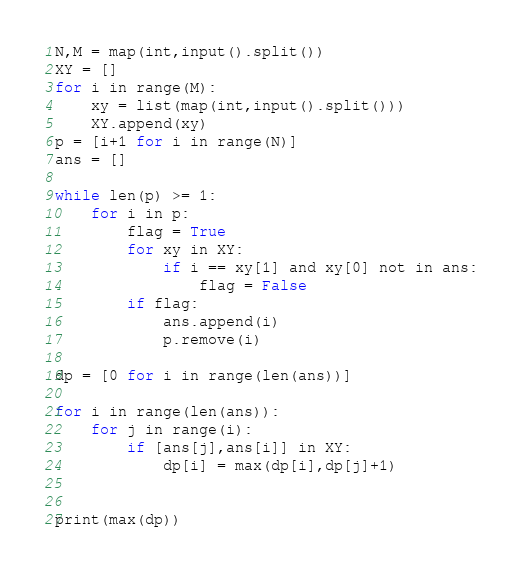Convert code to text. <code><loc_0><loc_0><loc_500><loc_500><_Python_>N,M = map(int,input().split())
XY = []
for i in range(M):
    xy = list(map(int,input().split()))
    XY.append(xy)
p = [i+1 for i in range(N)]
ans = []

while len(p) >= 1:
    for i in p:
        flag = True
        for xy in XY:
            if i == xy[1] and xy[0] not in ans:
                flag = False
        if flag:
            ans.append(i)
            p.remove(i)

dp = [0 for i in range(len(ans))]

for i in range(len(ans)):
    for j in range(i):
        if [ans[j],ans[i]] in XY:
            dp[i] = max(dp[i],dp[j]+1)


print(max(dp))        
</code> 